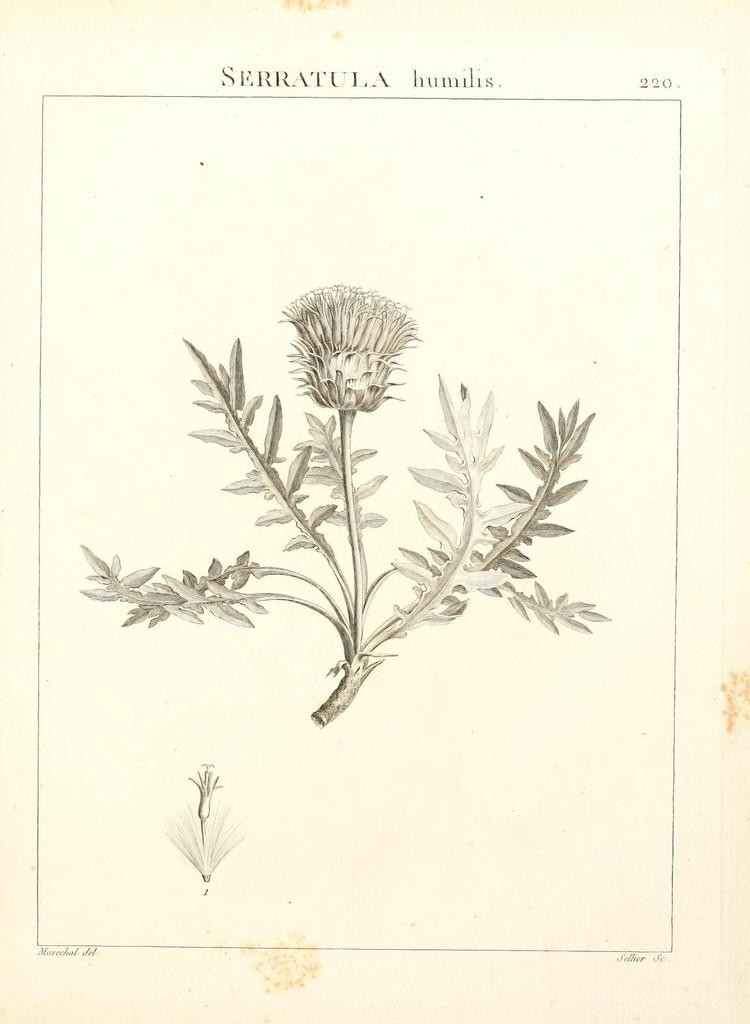What is the main subject of the image? There is a drawing of a plant in the center of the image. What can be seen above the drawing of the plant? There is text at the top of the image. What can be seen below the drawing of the plant? There is text at the bottom of the image. What is the size of the waste container in the image? There is no waste container present in the image. How many lines are visible in the drawing of the plant? The provided facts do not specify the number of lines in the drawing of the plant, so it cannot be determined from the image. 